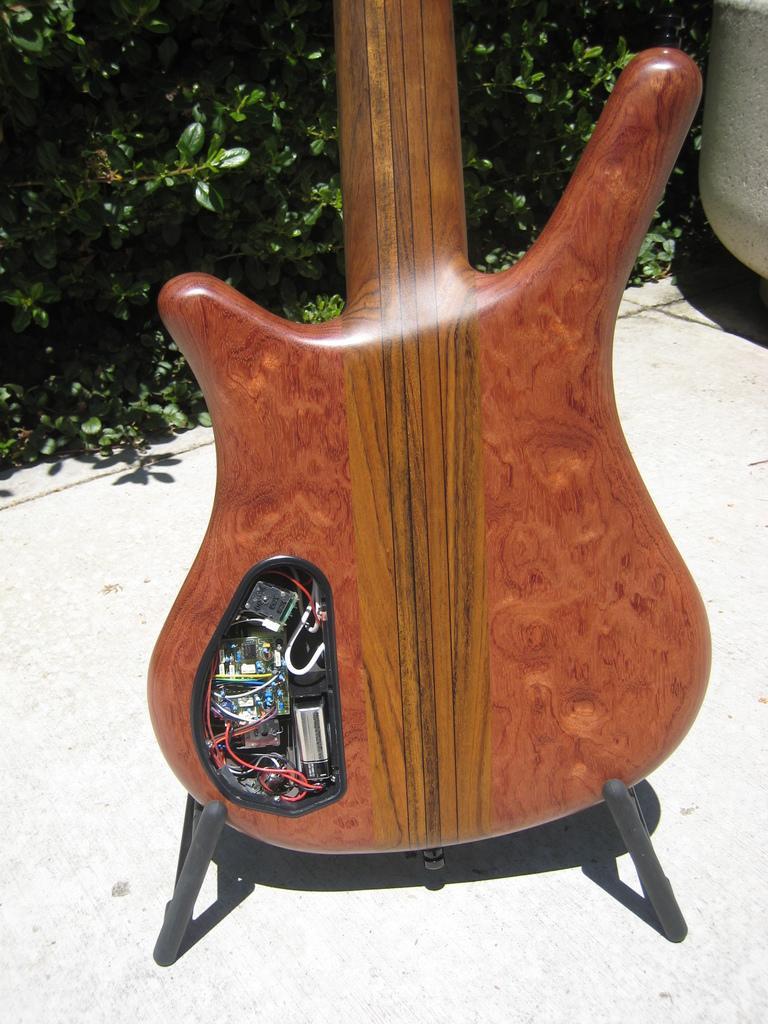Can you describe this image briefly? In the image we can see there is a guitar which is on the floor. 